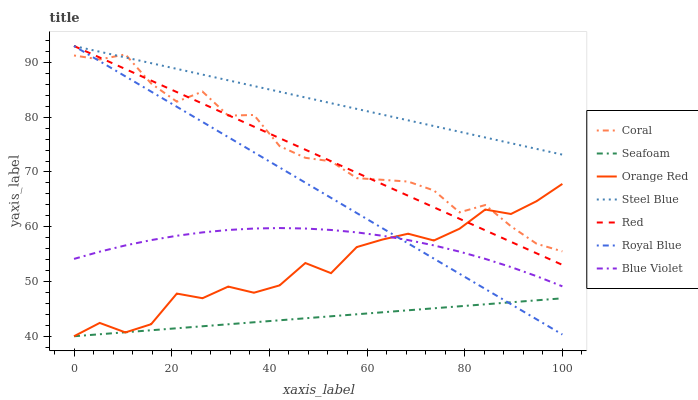Does Seafoam have the minimum area under the curve?
Answer yes or no. Yes. Does Steel Blue have the maximum area under the curve?
Answer yes or no. Yes. Does Steel Blue have the minimum area under the curve?
Answer yes or no. No. Does Seafoam have the maximum area under the curve?
Answer yes or no. No. Is Seafoam the smoothest?
Answer yes or no. Yes. Is Orange Red the roughest?
Answer yes or no. Yes. Is Steel Blue the smoothest?
Answer yes or no. No. Is Steel Blue the roughest?
Answer yes or no. No. Does Seafoam have the lowest value?
Answer yes or no. Yes. Does Steel Blue have the lowest value?
Answer yes or no. No. Does Red have the highest value?
Answer yes or no. Yes. Does Seafoam have the highest value?
Answer yes or no. No. Is Blue Violet less than Red?
Answer yes or no. Yes. Is Steel Blue greater than Seafoam?
Answer yes or no. Yes. Does Coral intersect Royal Blue?
Answer yes or no. Yes. Is Coral less than Royal Blue?
Answer yes or no. No. Is Coral greater than Royal Blue?
Answer yes or no. No. Does Blue Violet intersect Red?
Answer yes or no. No. 